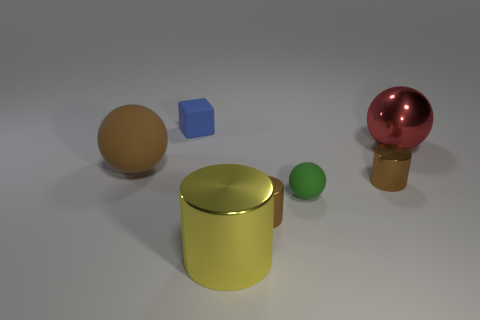Do the large ball that is on the left side of the large metal cylinder and the tiny cylinder in front of the green rubber sphere have the same color?
Give a very brief answer. Yes. Is the small brown cylinder that is in front of the green rubber sphere made of the same material as the big red object?
Keep it short and to the point. Yes. Are there an equal number of big red metallic things right of the small green object and large metallic spheres in front of the large red metallic sphere?
Your response must be concise. No. How big is the thing left of the tiny blue rubber object?
Keep it short and to the point. Large. Is there a big red thing made of the same material as the yellow object?
Provide a succinct answer. Yes. There is a tiny metallic thing in front of the tiny green sphere; is it the same color as the big rubber object?
Provide a succinct answer. Yes. Are there the same number of yellow shiny cylinders behind the small block and large balls?
Your answer should be very brief. No. Is there a metallic cylinder of the same color as the big metal ball?
Your answer should be compact. No. Is the block the same size as the green matte ball?
Give a very brief answer. Yes. There is a thing behind the sphere behind the large brown rubber thing; what is its size?
Give a very brief answer. Small. 